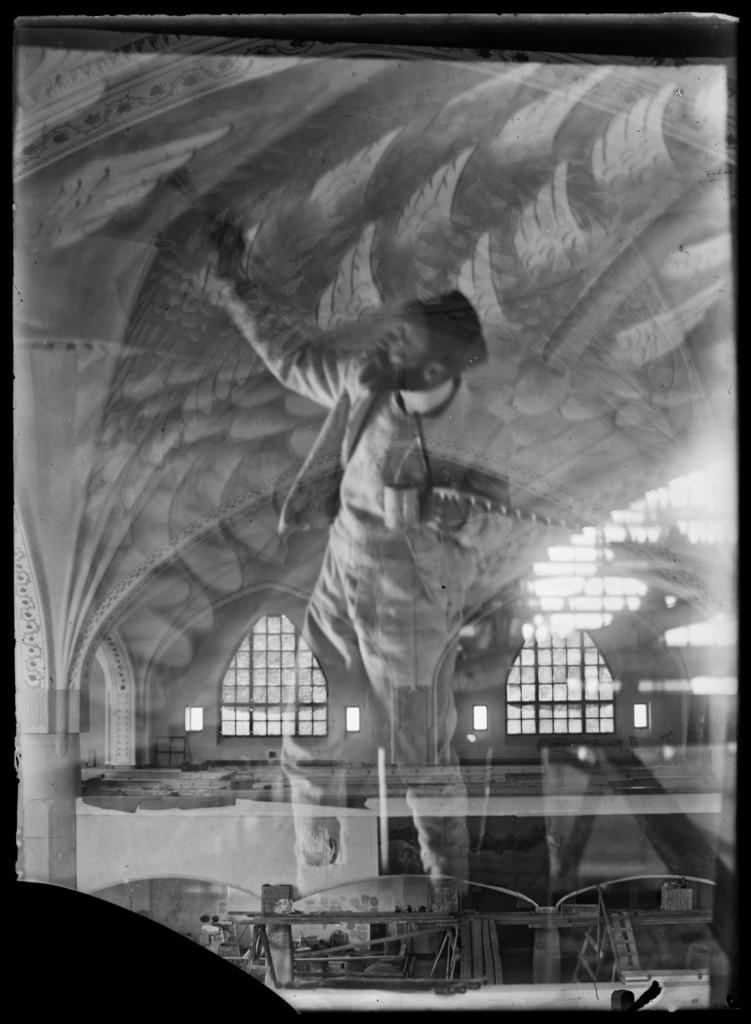What is the main subject of the image? There is a person standing in the image. What architectural feature can be seen in the image? There is an arch in the image. What can be seen in the background of the image? There are windows in the background of the image. How many oranges are being brushed with a toothbrush in the image? There are no oranges or toothbrushes present in the image. 